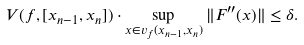Convert formula to latex. <formula><loc_0><loc_0><loc_500><loc_500>V ( f , [ x _ { n - 1 } , x _ { n } ] ) \cdot \sup _ { x \in v _ { f } ( x _ { n - 1 } , x _ { n } ) } \| F ^ { \prime \prime } ( x ) \| \leq \delta .</formula> 